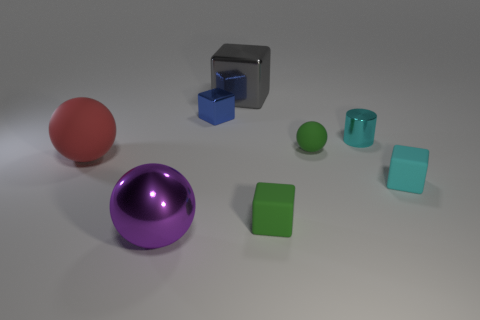Subtract all big spheres. How many spheres are left? 1 Add 1 big brown metal cylinders. How many objects exist? 9 Subtract all red blocks. Subtract all green cylinders. How many blocks are left? 4 Subtract all cylinders. How many objects are left? 7 Add 5 red rubber objects. How many red rubber objects are left? 6 Add 8 cyan metallic cubes. How many cyan metallic cubes exist? 8 Subtract 0 green cylinders. How many objects are left? 8 Subtract all green matte balls. Subtract all green matte cubes. How many objects are left? 6 